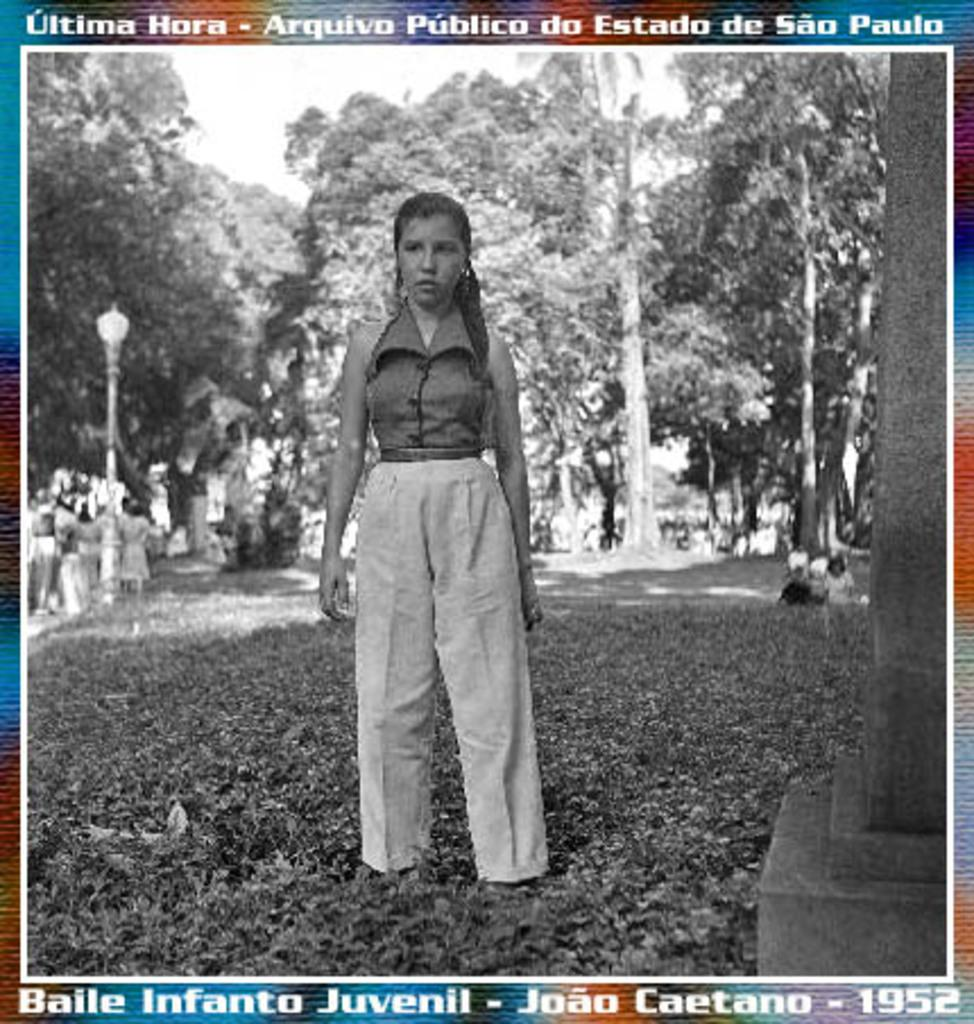What is the color scheme of the image? The image is black and white with a color border. What can be found on the border of the image? There is text written on the border. Who is present in the image? There is a woman standing in the image. What is the woman standing on? The woman is standing on grass. What can be seen in the background of the image? There are trees in the background of the image. How many sisters are present in the image? There is no mention of sisters in the image, as it only features a woman standing on grass. What type of cream is being distributed in the image? There is no cream or distribution process depicted in the image. 